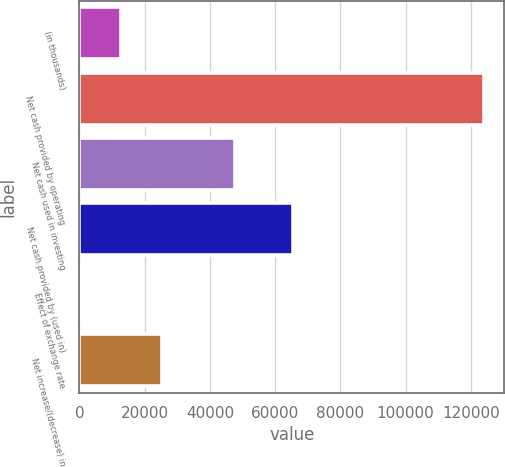Convert chart. <chart><loc_0><loc_0><loc_500><loc_500><bar_chart><fcel>(in thousands)<fcel>Net cash provided by operating<fcel>Net cash used in investing<fcel>Net cash provided by (used in)<fcel>Effect of exchange rate<fcel>Net increase/(decrease) in<nl><fcel>12853.5<fcel>124053<fcel>47645<fcel>65497<fcel>498<fcel>25209<nl></chart> 